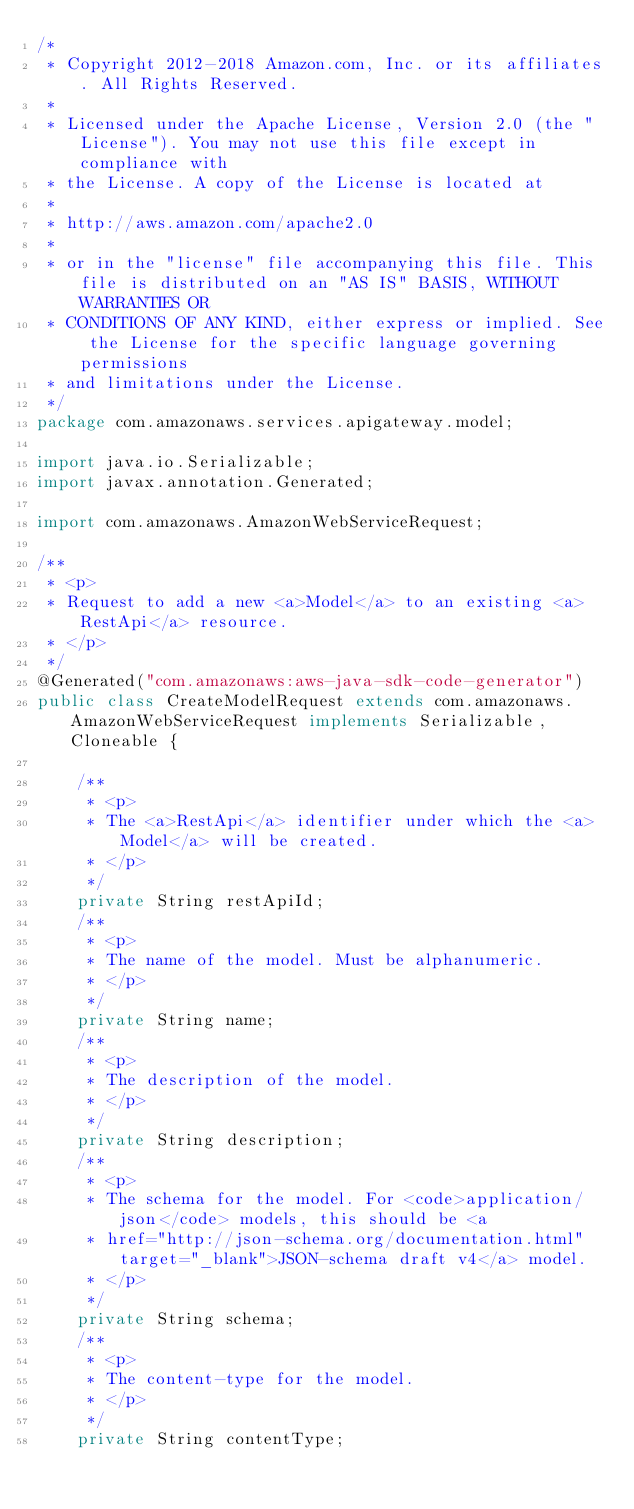<code> <loc_0><loc_0><loc_500><loc_500><_Java_>/*
 * Copyright 2012-2018 Amazon.com, Inc. or its affiliates. All Rights Reserved.
 * 
 * Licensed under the Apache License, Version 2.0 (the "License"). You may not use this file except in compliance with
 * the License. A copy of the License is located at
 * 
 * http://aws.amazon.com/apache2.0
 * 
 * or in the "license" file accompanying this file. This file is distributed on an "AS IS" BASIS, WITHOUT WARRANTIES OR
 * CONDITIONS OF ANY KIND, either express or implied. See the License for the specific language governing permissions
 * and limitations under the License.
 */
package com.amazonaws.services.apigateway.model;

import java.io.Serializable;
import javax.annotation.Generated;

import com.amazonaws.AmazonWebServiceRequest;

/**
 * <p>
 * Request to add a new <a>Model</a> to an existing <a>RestApi</a> resource.
 * </p>
 */
@Generated("com.amazonaws:aws-java-sdk-code-generator")
public class CreateModelRequest extends com.amazonaws.AmazonWebServiceRequest implements Serializable, Cloneable {

    /**
     * <p>
     * The <a>RestApi</a> identifier under which the <a>Model</a> will be created.
     * </p>
     */
    private String restApiId;
    /**
     * <p>
     * The name of the model. Must be alphanumeric.
     * </p>
     */
    private String name;
    /**
     * <p>
     * The description of the model.
     * </p>
     */
    private String description;
    /**
     * <p>
     * The schema for the model. For <code>application/json</code> models, this should be <a
     * href="http://json-schema.org/documentation.html" target="_blank">JSON-schema draft v4</a> model.
     * </p>
     */
    private String schema;
    /**
     * <p>
     * The content-type for the model.
     * </p>
     */
    private String contentType;
</code> 